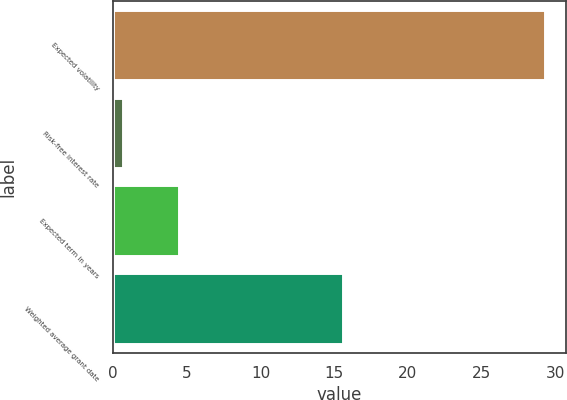Convert chart. <chart><loc_0><loc_0><loc_500><loc_500><bar_chart><fcel>Expected volatility<fcel>Risk-free interest rate<fcel>Expected term in years<fcel>Weighted average grant date<nl><fcel>29.27<fcel>0.7<fcel>4.5<fcel>15.58<nl></chart> 